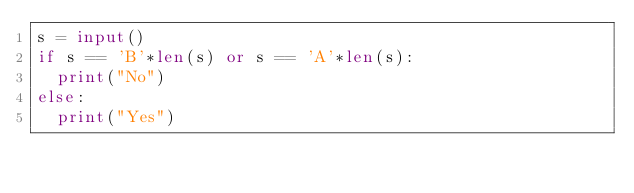<code> <loc_0><loc_0><loc_500><loc_500><_Python_>s = input()
if s == 'B'*len(s) or s == 'A'*len(s):
  print("No")
else:
  print("Yes")

</code> 